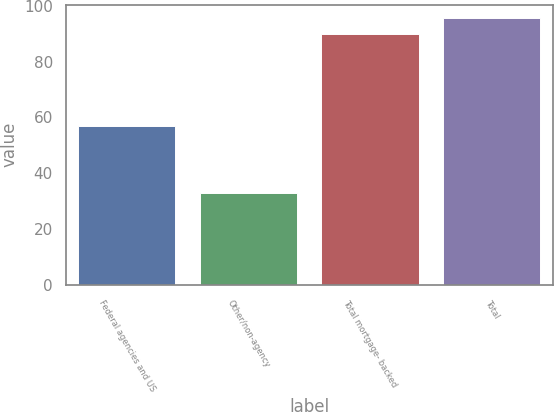Convert chart. <chart><loc_0><loc_0><loc_500><loc_500><bar_chart><fcel>Federal agencies and US<fcel>Other/non-agency<fcel>Total mortgage- backed<fcel>Total<nl><fcel>57<fcel>33<fcel>90<fcel>95.7<nl></chart> 